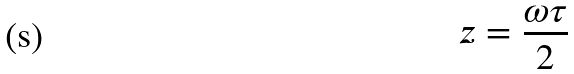Convert formula to latex. <formula><loc_0><loc_0><loc_500><loc_500>z = \frac { \omega \tau } { 2 }</formula> 